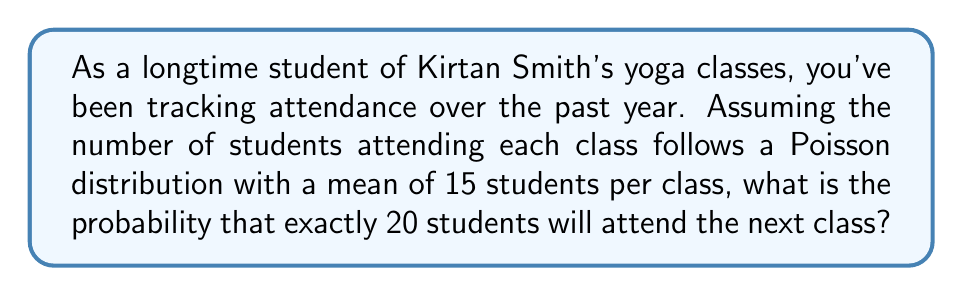Show me your answer to this math problem. To solve this problem, we'll use the Poisson distribution formula:

$$P(X = k) = \frac{e^{-\lambda} \lambda^k}{k!}$$

Where:
$\lambda$ = mean number of occurrences
$k$ = number of occurrences we're calculating the probability for
$e$ = Euler's number (approximately 2.71828)

Given:
$\lambda = 15$ (mean attendance)
$k = 20$ (number of students we're interested in)

Step 1: Plug the values into the formula
$$P(X = 20) = \frac{e^{-15} 15^{20}}{20!}$$

Step 2: Calculate $e^{-15}$
$$e^{-15} \approx 3.059 \times 10^{-7}$$

Step 3: Calculate $15^{20}$
$$15^{20} \approx 3.269 \times 10^{23}$$

Step 4: Calculate $20!$
$$20! = 2.433 \times 10^{18}$$

Step 5: Put it all together
$$P(X = 20) = \frac{(3.059 \times 10^{-7})(3.269 \times 10^{23})}{2.433 \times 10^{18}}$$

Step 6: Simplify
$$P(X = 20) \approx 0.0409$$

Therefore, the probability of exactly 20 students attending the next class is approximately 0.0409 or 4.09%.
Answer: 0.0409 